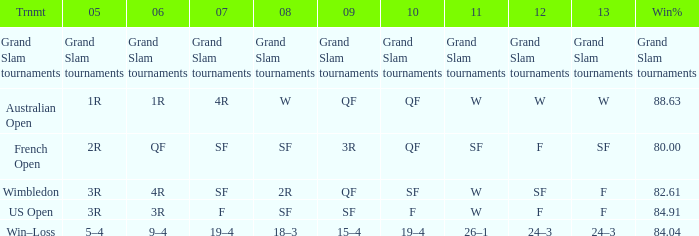WHat in 2005 has a Win % of 82.61? 3R. 